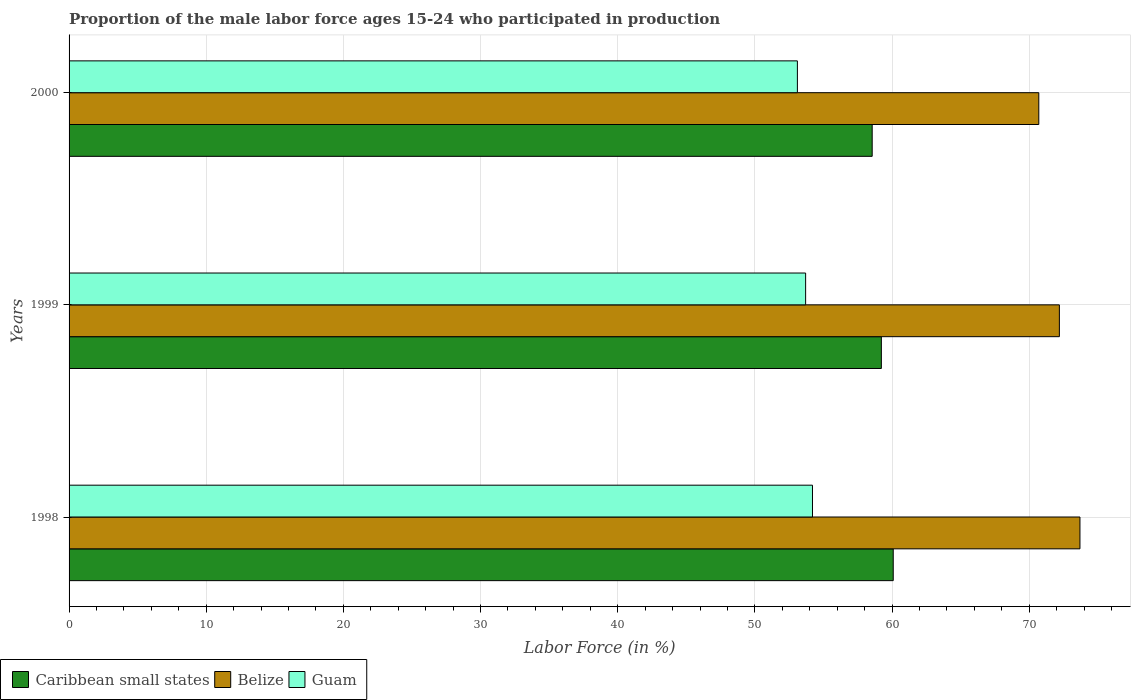How many groups of bars are there?
Your response must be concise. 3. Are the number of bars per tick equal to the number of legend labels?
Offer a very short reply. Yes. Are the number of bars on each tick of the Y-axis equal?
Provide a succinct answer. Yes. How many bars are there on the 1st tick from the bottom?
Ensure brevity in your answer.  3. What is the proportion of the male labor force who participated in production in Belize in 1999?
Give a very brief answer. 72.2. Across all years, what is the maximum proportion of the male labor force who participated in production in Belize?
Make the answer very short. 73.7. Across all years, what is the minimum proportion of the male labor force who participated in production in Guam?
Give a very brief answer. 53.1. In which year was the proportion of the male labor force who participated in production in Guam maximum?
Offer a very short reply. 1998. What is the total proportion of the male labor force who participated in production in Belize in the graph?
Offer a terse response. 216.6. What is the difference between the proportion of the male labor force who participated in production in Caribbean small states in 1998 and that in 1999?
Keep it short and to the point. 0.87. What is the difference between the proportion of the male labor force who participated in production in Caribbean small states in 2000 and the proportion of the male labor force who participated in production in Belize in 1999?
Keep it short and to the point. -13.65. What is the average proportion of the male labor force who participated in production in Guam per year?
Your answer should be compact. 53.67. In the year 1998, what is the difference between the proportion of the male labor force who participated in production in Caribbean small states and proportion of the male labor force who participated in production in Guam?
Offer a terse response. 5.89. In how many years, is the proportion of the male labor force who participated in production in Belize greater than 34 %?
Offer a terse response. 3. What is the ratio of the proportion of the male labor force who participated in production in Belize in 1999 to that in 2000?
Provide a succinct answer. 1.02. Is the proportion of the male labor force who participated in production in Caribbean small states in 1998 less than that in 2000?
Provide a succinct answer. No. What is the difference between the highest and the second highest proportion of the male labor force who participated in production in Caribbean small states?
Your response must be concise. 0.87. What does the 2nd bar from the top in 2000 represents?
Offer a very short reply. Belize. What does the 2nd bar from the bottom in 1999 represents?
Keep it short and to the point. Belize. Is it the case that in every year, the sum of the proportion of the male labor force who participated in production in Guam and proportion of the male labor force who participated in production in Belize is greater than the proportion of the male labor force who participated in production in Caribbean small states?
Keep it short and to the point. Yes. What is the difference between two consecutive major ticks on the X-axis?
Provide a short and direct response. 10. Does the graph contain grids?
Offer a terse response. Yes. What is the title of the graph?
Your answer should be compact. Proportion of the male labor force ages 15-24 who participated in production. Does "Norway" appear as one of the legend labels in the graph?
Give a very brief answer. No. What is the Labor Force (in %) in Caribbean small states in 1998?
Make the answer very short. 60.09. What is the Labor Force (in %) in Belize in 1998?
Your response must be concise. 73.7. What is the Labor Force (in %) in Guam in 1998?
Keep it short and to the point. 54.2. What is the Labor Force (in %) in Caribbean small states in 1999?
Make the answer very short. 59.22. What is the Labor Force (in %) in Belize in 1999?
Offer a terse response. 72.2. What is the Labor Force (in %) of Guam in 1999?
Offer a very short reply. 53.7. What is the Labor Force (in %) in Caribbean small states in 2000?
Offer a very short reply. 58.55. What is the Labor Force (in %) of Belize in 2000?
Give a very brief answer. 70.7. What is the Labor Force (in %) in Guam in 2000?
Your response must be concise. 53.1. Across all years, what is the maximum Labor Force (in %) in Caribbean small states?
Provide a succinct answer. 60.09. Across all years, what is the maximum Labor Force (in %) of Belize?
Offer a terse response. 73.7. Across all years, what is the maximum Labor Force (in %) of Guam?
Provide a succinct answer. 54.2. Across all years, what is the minimum Labor Force (in %) in Caribbean small states?
Provide a succinct answer. 58.55. Across all years, what is the minimum Labor Force (in %) of Belize?
Ensure brevity in your answer.  70.7. Across all years, what is the minimum Labor Force (in %) in Guam?
Your answer should be compact. 53.1. What is the total Labor Force (in %) of Caribbean small states in the graph?
Offer a terse response. 177.86. What is the total Labor Force (in %) of Belize in the graph?
Keep it short and to the point. 216.6. What is the total Labor Force (in %) in Guam in the graph?
Offer a very short reply. 161. What is the difference between the Labor Force (in %) of Caribbean small states in 1998 and that in 1999?
Your answer should be compact. 0.87. What is the difference between the Labor Force (in %) in Belize in 1998 and that in 1999?
Offer a very short reply. 1.5. What is the difference between the Labor Force (in %) of Caribbean small states in 1998 and that in 2000?
Provide a succinct answer. 1.53. What is the difference between the Labor Force (in %) in Caribbean small states in 1999 and that in 2000?
Offer a very short reply. 0.67. What is the difference between the Labor Force (in %) in Belize in 1999 and that in 2000?
Make the answer very short. 1.5. What is the difference between the Labor Force (in %) of Caribbean small states in 1998 and the Labor Force (in %) of Belize in 1999?
Make the answer very short. -12.11. What is the difference between the Labor Force (in %) of Caribbean small states in 1998 and the Labor Force (in %) of Guam in 1999?
Your response must be concise. 6.39. What is the difference between the Labor Force (in %) in Belize in 1998 and the Labor Force (in %) in Guam in 1999?
Provide a succinct answer. 20. What is the difference between the Labor Force (in %) of Caribbean small states in 1998 and the Labor Force (in %) of Belize in 2000?
Keep it short and to the point. -10.61. What is the difference between the Labor Force (in %) of Caribbean small states in 1998 and the Labor Force (in %) of Guam in 2000?
Offer a terse response. 6.99. What is the difference between the Labor Force (in %) of Belize in 1998 and the Labor Force (in %) of Guam in 2000?
Offer a terse response. 20.6. What is the difference between the Labor Force (in %) of Caribbean small states in 1999 and the Labor Force (in %) of Belize in 2000?
Your answer should be compact. -11.48. What is the difference between the Labor Force (in %) of Caribbean small states in 1999 and the Labor Force (in %) of Guam in 2000?
Your response must be concise. 6.12. What is the average Labor Force (in %) in Caribbean small states per year?
Your response must be concise. 59.29. What is the average Labor Force (in %) of Belize per year?
Provide a short and direct response. 72.2. What is the average Labor Force (in %) in Guam per year?
Make the answer very short. 53.67. In the year 1998, what is the difference between the Labor Force (in %) in Caribbean small states and Labor Force (in %) in Belize?
Offer a very short reply. -13.61. In the year 1998, what is the difference between the Labor Force (in %) of Caribbean small states and Labor Force (in %) of Guam?
Provide a short and direct response. 5.89. In the year 1998, what is the difference between the Labor Force (in %) in Belize and Labor Force (in %) in Guam?
Offer a very short reply. 19.5. In the year 1999, what is the difference between the Labor Force (in %) of Caribbean small states and Labor Force (in %) of Belize?
Your response must be concise. -12.98. In the year 1999, what is the difference between the Labor Force (in %) of Caribbean small states and Labor Force (in %) of Guam?
Offer a terse response. 5.52. In the year 2000, what is the difference between the Labor Force (in %) in Caribbean small states and Labor Force (in %) in Belize?
Ensure brevity in your answer.  -12.15. In the year 2000, what is the difference between the Labor Force (in %) of Caribbean small states and Labor Force (in %) of Guam?
Your answer should be very brief. 5.45. What is the ratio of the Labor Force (in %) in Caribbean small states in 1998 to that in 1999?
Your response must be concise. 1.01. What is the ratio of the Labor Force (in %) in Belize in 1998 to that in 1999?
Your response must be concise. 1.02. What is the ratio of the Labor Force (in %) of Guam in 1998 to that in 1999?
Your answer should be compact. 1.01. What is the ratio of the Labor Force (in %) in Caribbean small states in 1998 to that in 2000?
Your answer should be compact. 1.03. What is the ratio of the Labor Force (in %) of Belize in 1998 to that in 2000?
Give a very brief answer. 1.04. What is the ratio of the Labor Force (in %) in Guam in 1998 to that in 2000?
Provide a succinct answer. 1.02. What is the ratio of the Labor Force (in %) of Caribbean small states in 1999 to that in 2000?
Make the answer very short. 1.01. What is the ratio of the Labor Force (in %) of Belize in 1999 to that in 2000?
Keep it short and to the point. 1.02. What is the ratio of the Labor Force (in %) of Guam in 1999 to that in 2000?
Your answer should be compact. 1.01. What is the difference between the highest and the second highest Labor Force (in %) of Caribbean small states?
Provide a short and direct response. 0.87. What is the difference between the highest and the second highest Labor Force (in %) in Guam?
Your answer should be very brief. 0.5. What is the difference between the highest and the lowest Labor Force (in %) of Caribbean small states?
Give a very brief answer. 1.53. What is the difference between the highest and the lowest Labor Force (in %) of Belize?
Provide a succinct answer. 3. What is the difference between the highest and the lowest Labor Force (in %) in Guam?
Ensure brevity in your answer.  1.1. 